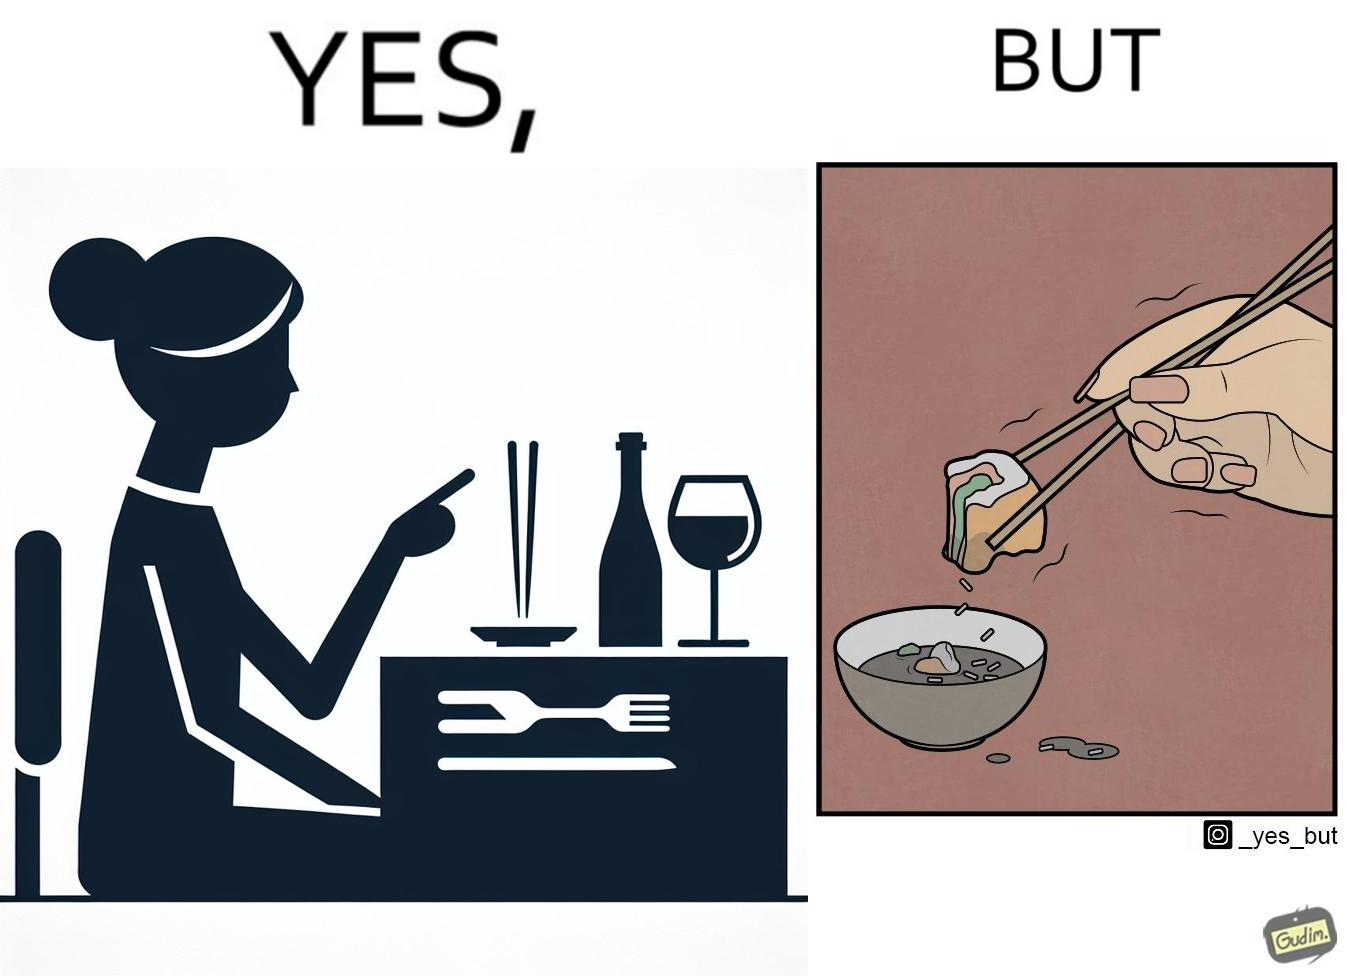What do you see in each half of this image? In the left part of the image: The image shows a woman sitting at a table in a restaruant pointing to chopsticks on her table. There is also a wine glass, a fork and a knief on her table. In the right part of the image: The image shows a person using chopstick to pick up food from the cup. The person is not able to handle food with chopstick well and is dropping the food around the cup on the table. 